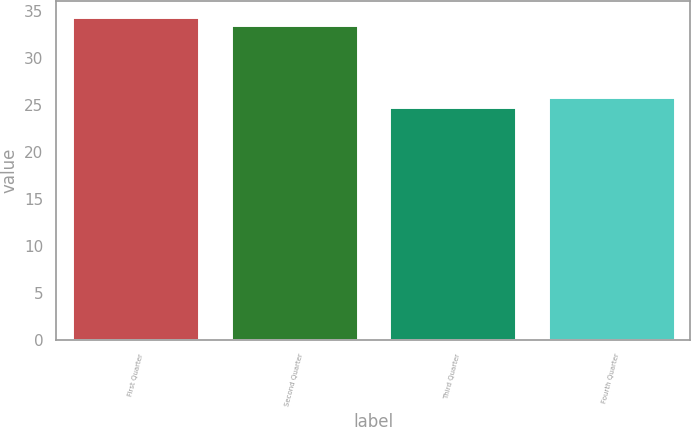<chart> <loc_0><loc_0><loc_500><loc_500><bar_chart><fcel>First Quarter<fcel>Second Quarter<fcel>Third Quarter<fcel>Fourth Quarter<nl><fcel>34.35<fcel>33.47<fcel>24.74<fcel>25.8<nl></chart> 